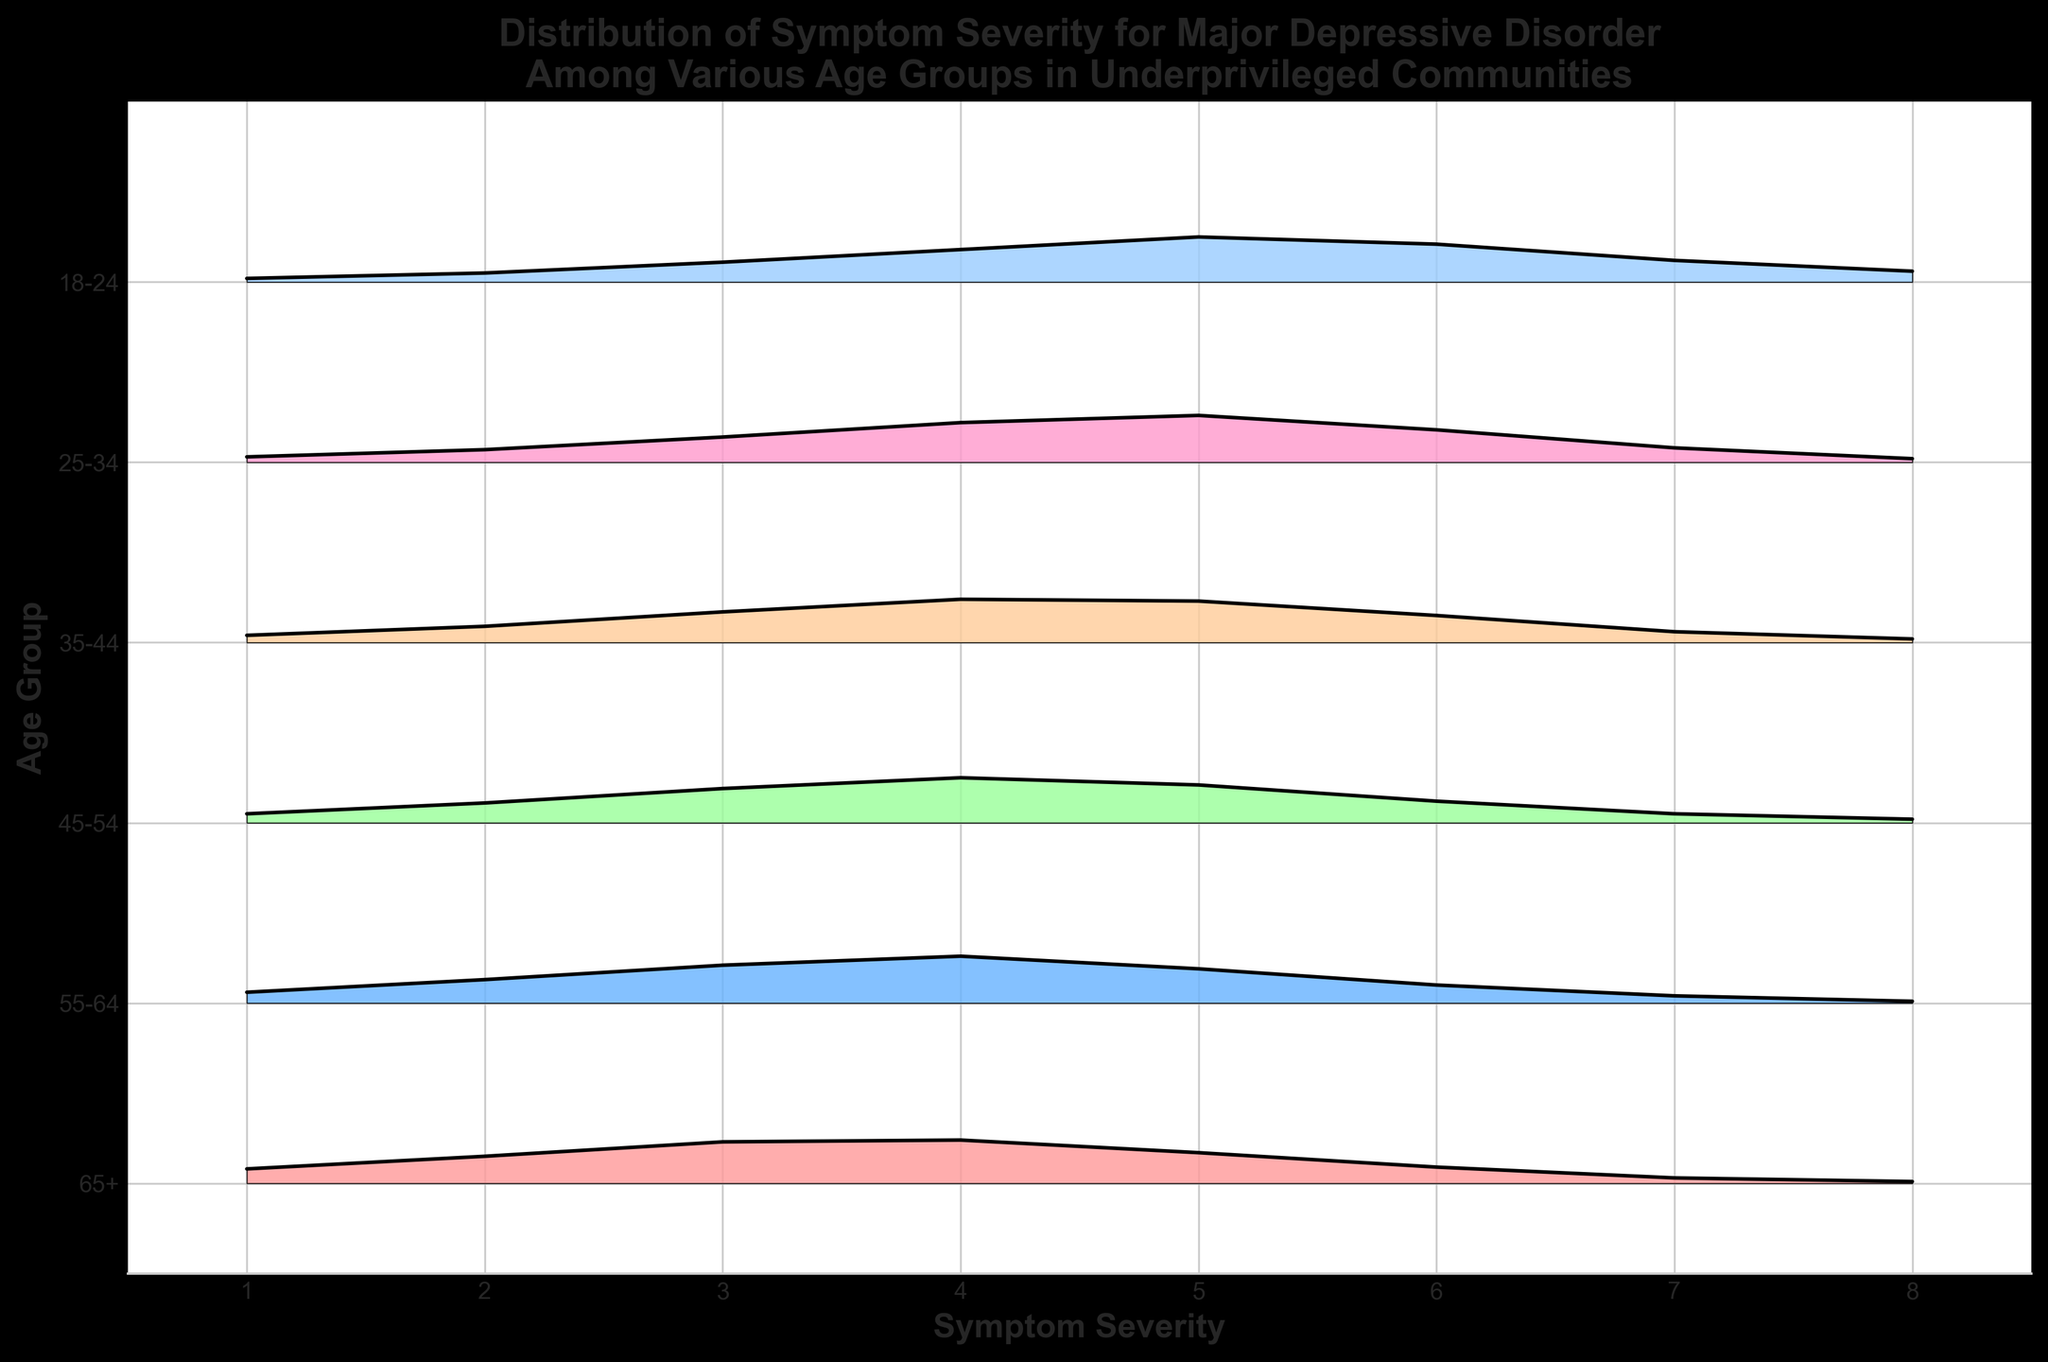What is the title of the figure? The title is located at the top center of the plot and highlights the main theme of the figure. It states the type of data and the specific demographic being studied.
Answer: Distribution of Symptom Severity for Major Depressive Disorder Among Various Age Groups in Underprivileged Communities How many age groups are represented in the plot? To determine the number of age groups, count the unique labels along the y-axis, each representing a different age group.
Answer: Six Which age group shows the highest density for a symptom severity of 4? By examining the lines and fill areas at severity level 4, identify the peak densities for each age group and compare them. The group with the highest peak at this severity is the answer.
Answer: 55-64 How does the symptom severity distribution for the 65+ age group compare to the 18-24 age group? Compare the shapes of the distribution (hills and valleys) for both age groups. The symmetry, spread, and peak positions of both distributions are evaluated.
Answer: The 65+ age group has a wider spread and peaks slightly higher at lower severities compared to the 18-24 group What is the most common symptom severity for the 35-44 age group? Look for the highest density peak in the distribution for the 35-44 age group. The symptom severity corresponding to this peak is the most common.
Answer: 4 Which age group shows the highest density for the lowest symptom severity (1)? Identify and compare the densities at symptom severity 1 across all age groups. The group with the highest density at this severity is selected.
Answer: 65+ What is the general trend in symptom severity distributions as age increases? Examine the overall shapes of the distributions from each age group, noting the shift or stability of peak densities as age increases. Determine if there is a pattern like shifting peaks or changes in spread.
Answer: As age increases, peak symptom severity tends to decrease, and distributions become wider For the 25-34 age group, which symptom severity has less density—severity 2 or severity 7? Compare the density values at severity 2 and severity 7 in the 25-34 age group. The severity with the smaller density value is the answer.
Answer: Severity 7 What can be inferred about the variability in symptom severity across different age groups? Study the variations (spread of the hills) in the ridgeline plot for each age group to understand how symptom severity fluctuates within each group. Summarize the observations of consistency or spread across groups.
Answer: Older age groups tend to have a wider spread, indicating more variability in symptom severity, while younger groups like 18-24 have more concentrated peak severities Which age group has the narrowest distribution of symptom severities? Evaluate the spread of the distributions (width of the hills) for all age groups and find the one with the least spread, indicating less variability.
Answer: 18-24 